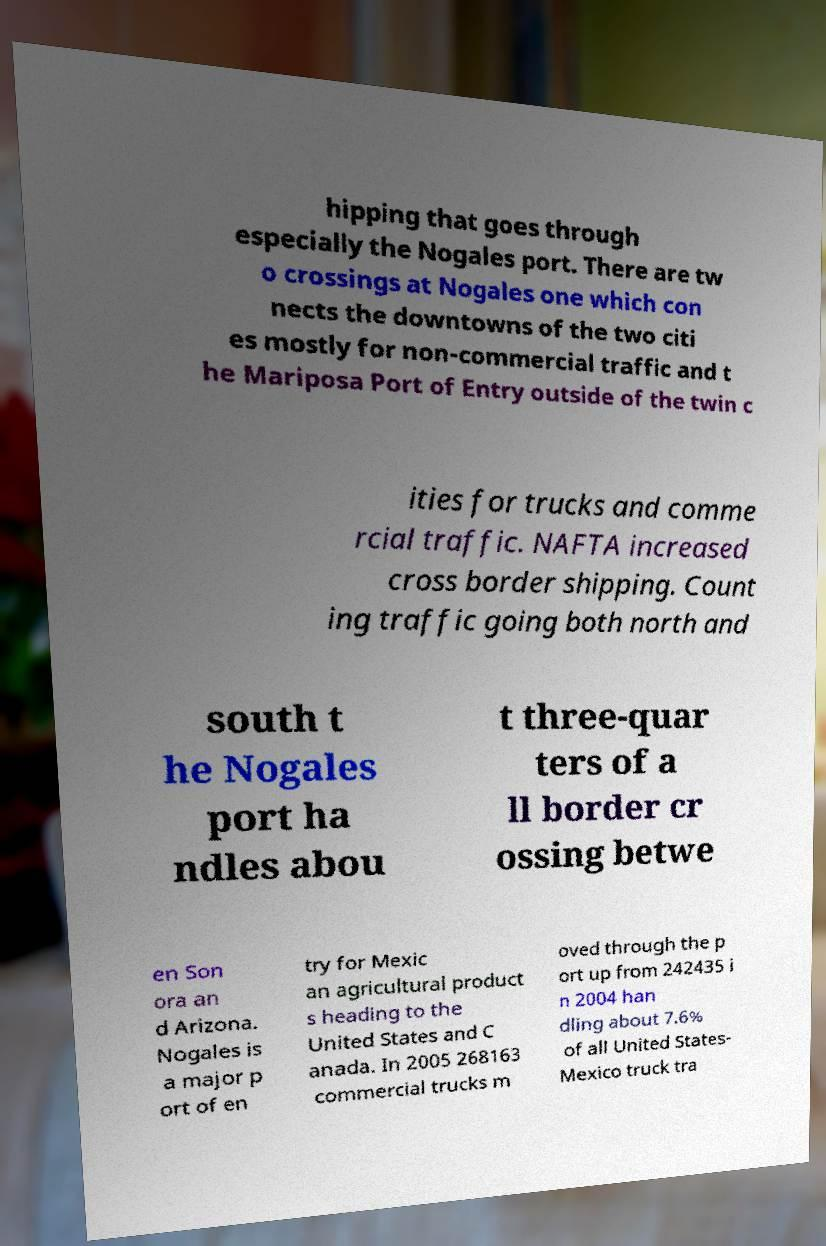Please read and relay the text visible in this image. What does it say? hipping that goes through especially the Nogales port. There are tw o crossings at Nogales one which con nects the downtowns of the two citi es mostly for non-commercial traffic and t he Mariposa Port of Entry outside of the twin c ities for trucks and comme rcial traffic. NAFTA increased cross border shipping. Count ing traffic going both north and south t he Nogales port ha ndles abou t three-quar ters of a ll border cr ossing betwe en Son ora an d Arizona. Nogales is a major p ort of en try for Mexic an agricultural product s heading to the United States and C anada. In 2005 268163 commercial trucks m oved through the p ort up from 242435 i n 2004 han dling about 7.6% of all United States- Mexico truck tra 